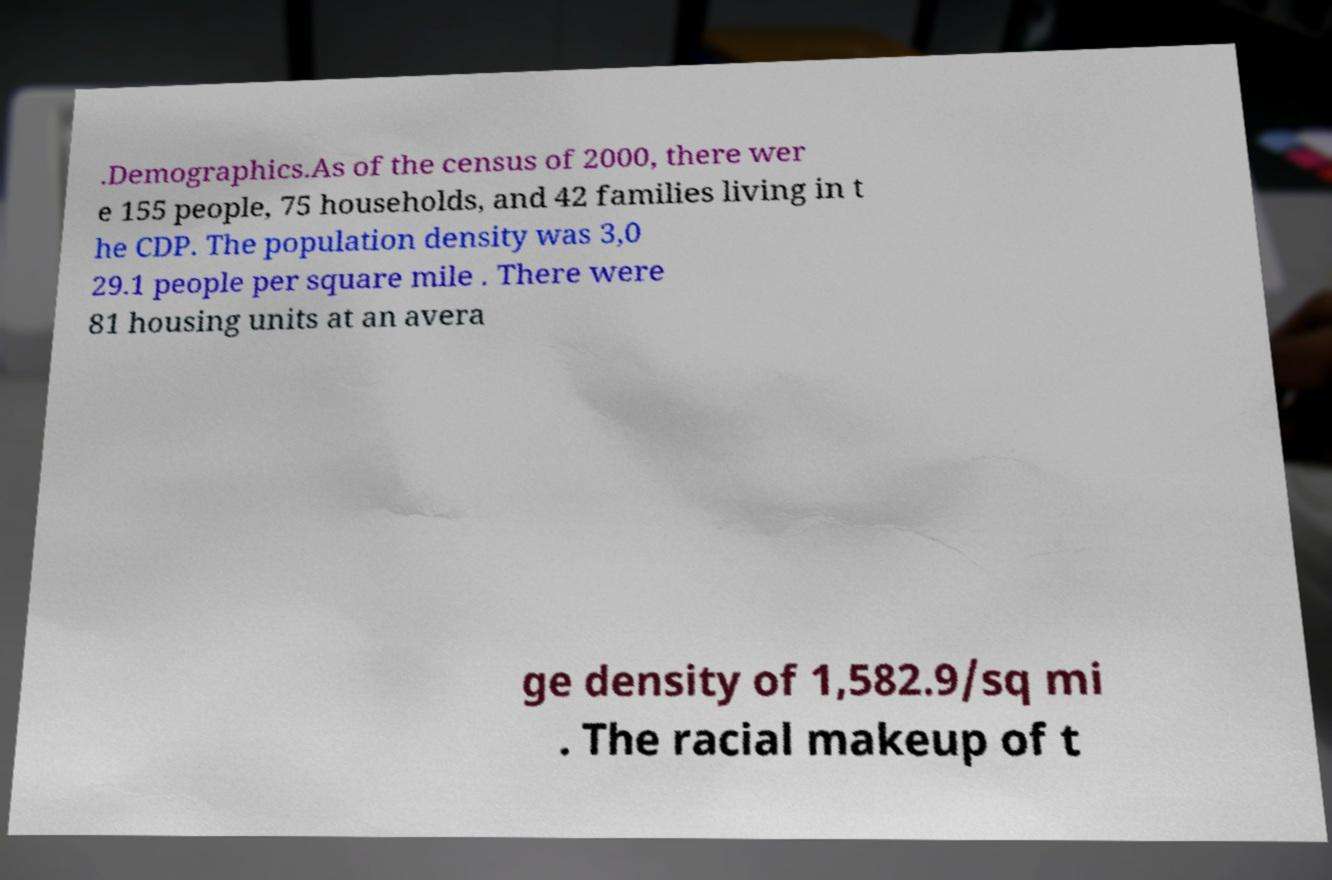Could you extract and type out the text from this image? .Demographics.As of the census of 2000, there wer e 155 people, 75 households, and 42 families living in t he CDP. The population density was 3,0 29.1 people per square mile . There were 81 housing units at an avera ge density of 1,582.9/sq mi . The racial makeup of t 